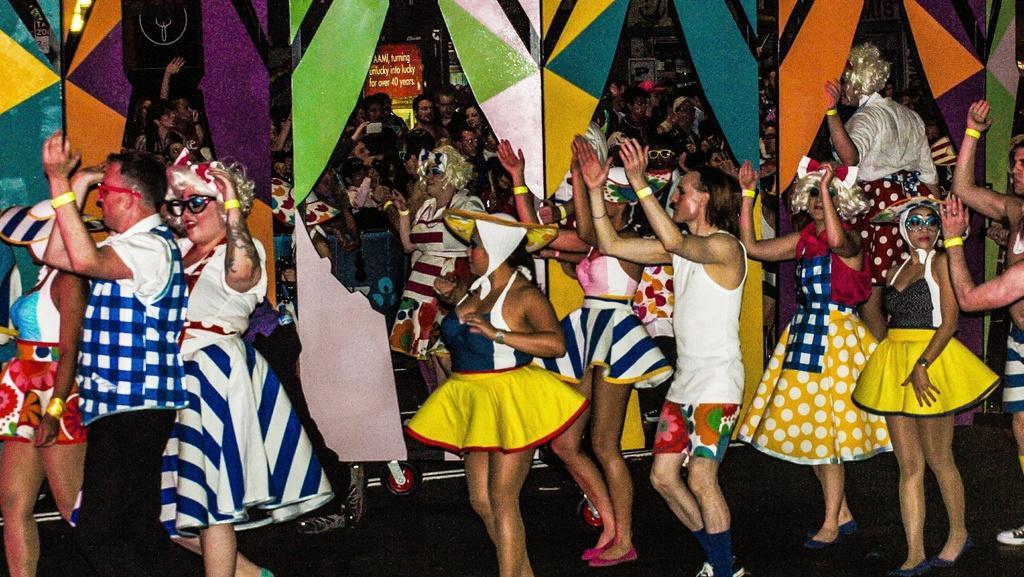Please provide a concise description of this image. In this image there are so many people wearing drama costumes and dancing in the hall behind them there is a wall. 